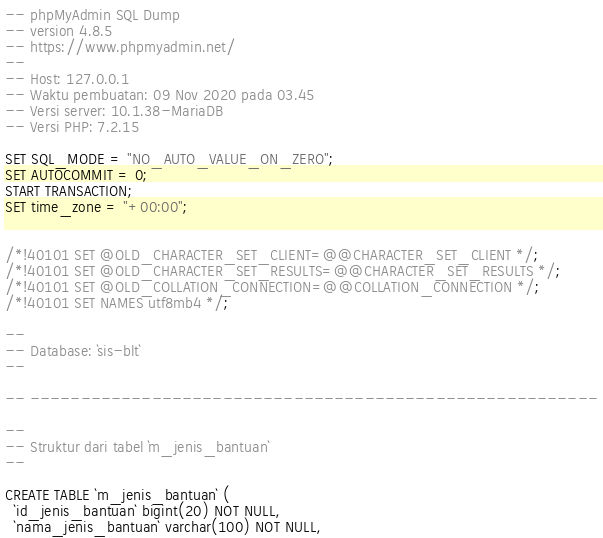<code> <loc_0><loc_0><loc_500><loc_500><_SQL_>-- phpMyAdmin SQL Dump
-- version 4.8.5
-- https://www.phpmyadmin.net/
--
-- Host: 127.0.0.1
-- Waktu pembuatan: 09 Nov 2020 pada 03.45
-- Versi server: 10.1.38-MariaDB
-- Versi PHP: 7.2.15

SET SQL_MODE = "NO_AUTO_VALUE_ON_ZERO";
SET AUTOCOMMIT = 0;
START TRANSACTION;
SET time_zone = "+00:00";


/*!40101 SET @OLD_CHARACTER_SET_CLIENT=@@CHARACTER_SET_CLIENT */;
/*!40101 SET @OLD_CHARACTER_SET_RESULTS=@@CHARACTER_SET_RESULTS */;
/*!40101 SET @OLD_COLLATION_CONNECTION=@@COLLATION_CONNECTION */;
/*!40101 SET NAMES utf8mb4 */;

--
-- Database: `sis-blt`
--

-- --------------------------------------------------------

--
-- Struktur dari tabel `m_jenis_bantuan`
--

CREATE TABLE `m_jenis_bantuan` (
  `id_jenis_bantuan` bigint(20) NOT NULL,
  `nama_jenis_bantuan` varchar(100) NOT NULL,</code> 